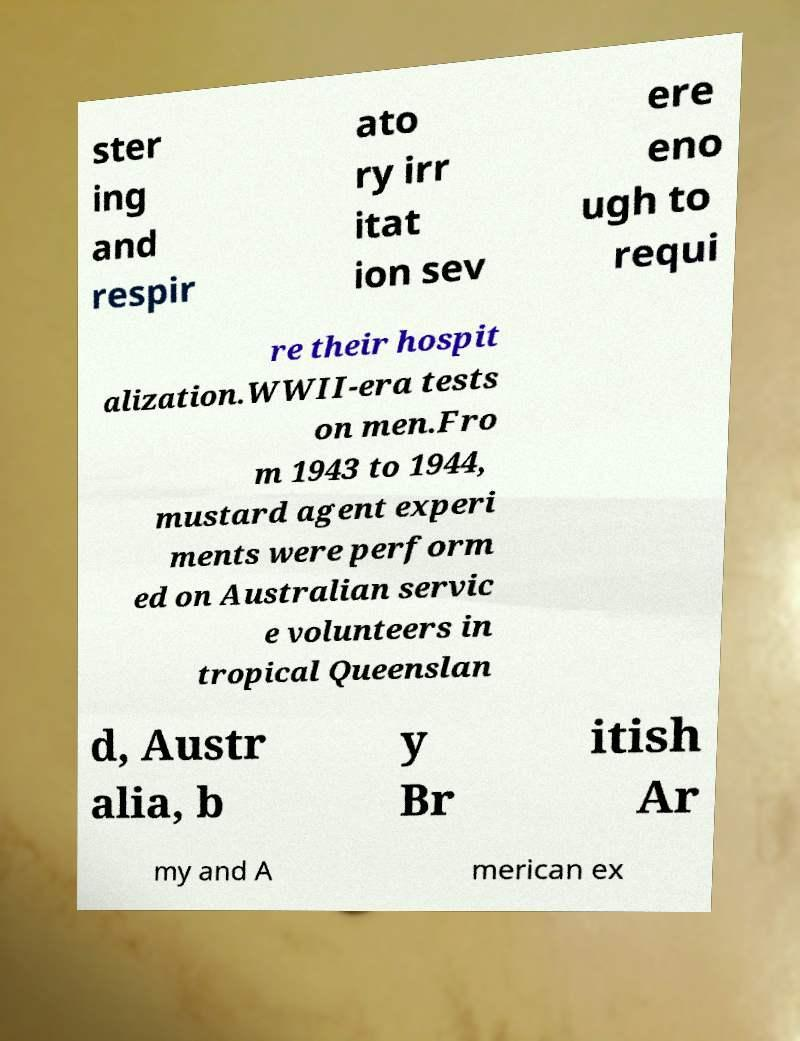Please identify and transcribe the text found in this image. ster ing and respir ato ry irr itat ion sev ere eno ugh to requi re their hospit alization.WWII-era tests on men.Fro m 1943 to 1944, mustard agent experi ments were perform ed on Australian servic e volunteers in tropical Queenslan d, Austr alia, b y Br itish Ar my and A merican ex 